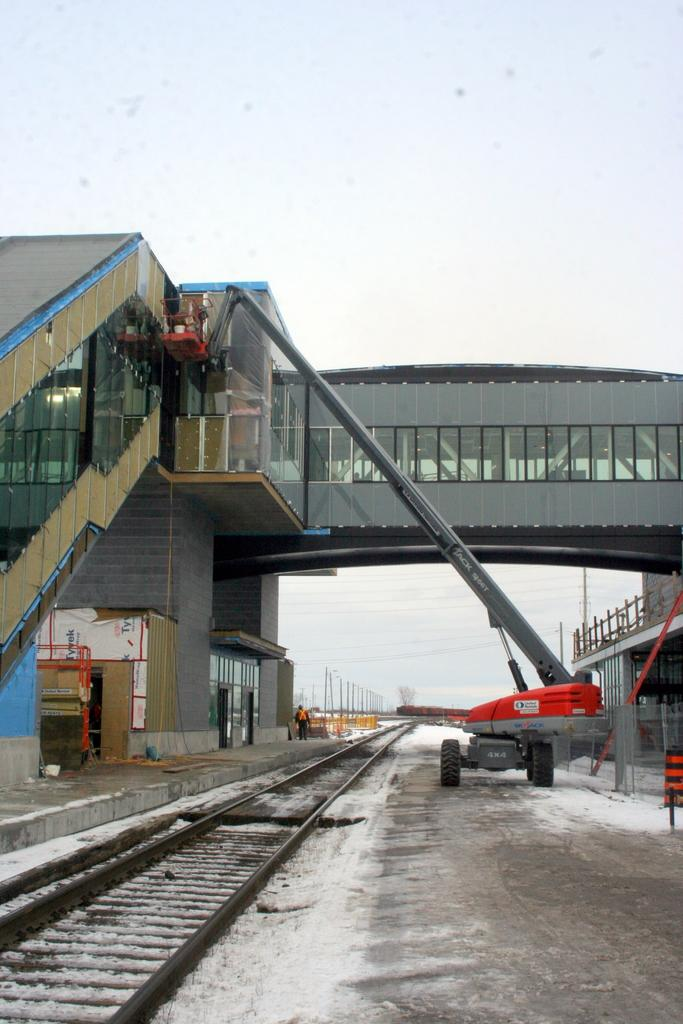What is the main feature of the image? There is a track in the image. What can be seen near the track? There is a vehicle near the track. What type of structure is present in the image? There is a bridge in the image, and it is grey. What can be seen in the background of the image? The sky is visible in the image, and it is white. What type of music can be heard playing in the background of the image? There is no music present in the image, as it is a visual representation and does not include sound. 